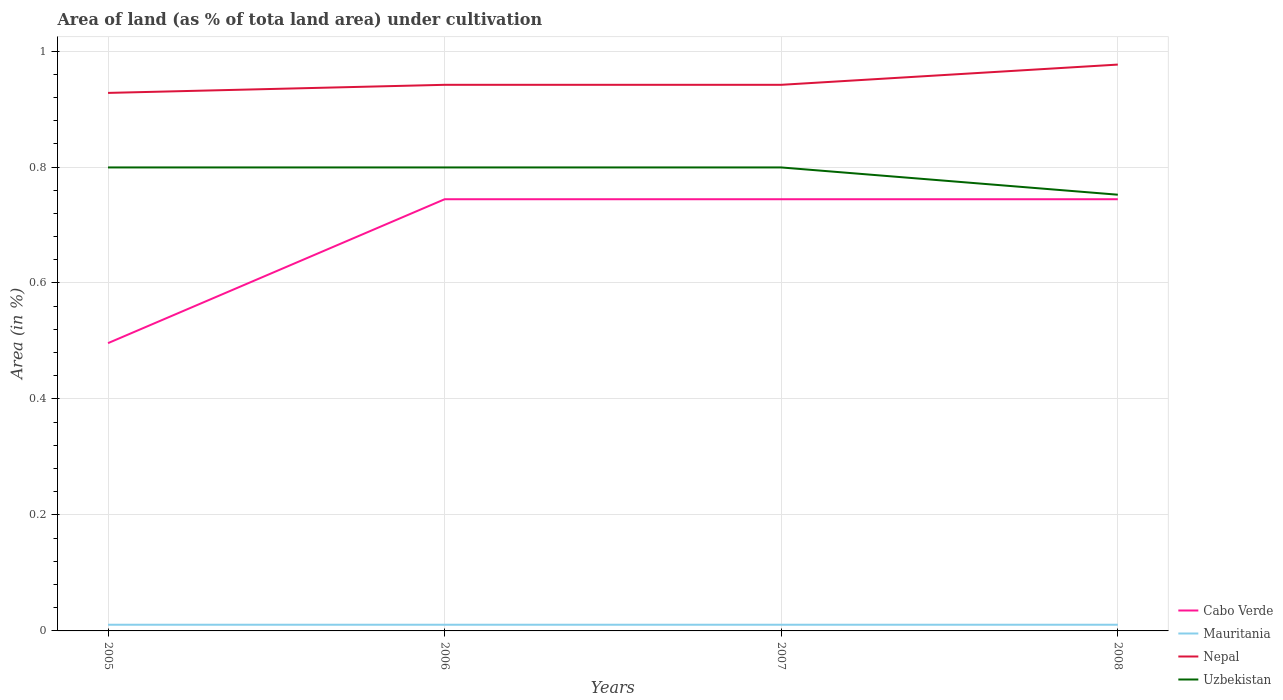How many different coloured lines are there?
Give a very brief answer. 4. Is the number of lines equal to the number of legend labels?
Keep it short and to the point. Yes. Across all years, what is the maximum percentage of land under cultivation in Nepal?
Offer a very short reply. 0.93. In which year was the percentage of land under cultivation in Mauritania maximum?
Provide a short and direct response. 2005. What is the total percentage of land under cultivation in Nepal in the graph?
Ensure brevity in your answer.  -0.03. What is the difference between the highest and the second highest percentage of land under cultivation in Cabo Verde?
Your answer should be very brief. 0.25. How many years are there in the graph?
Provide a short and direct response. 4. Does the graph contain grids?
Your response must be concise. Yes. Where does the legend appear in the graph?
Ensure brevity in your answer.  Bottom right. How many legend labels are there?
Provide a succinct answer. 4. What is the title of the graph?
Give a very brief answer. Area of land (as % of tota land area) under cultivation. What is the label or title of the Y-axis?
Offer a very short reply. Area (in %). What is the Area (in %) of Cabo Verde in 2005?
Ensure brevity in your answer.  0.5. What is the Area (in %) in Mauritania in 2005?
Your response must be concise. 0.01. What is the Area (in %) of Nepal in 2005?
Offer a very short reply. 0.93. What is the Area (in %) of Uzbekistan in 2005?
Offer a terse response. 0.8. What is the Area (in %) in Cabo Verde in 2006?
Ensure brevity in your answer.  0.74. What is the Area (in %) in Mauritania in 2006?
Ensure brevity in your answer.  0.01. What is the Area (in %) in Nepal in 2006?
Keep it short and to the point. 0.94. What is the Area (in %) of Uzbekistan in 2006?
Your answer should be compact. 0.8. What is the Area (in %) of Cabo Verde in 2007?
Ensure brevity in your answer.  0.74. What is the Area (in %) in Mauritania in 2007?
Ensure brevity in your answer.  0.01. What is the Area (in %) in Nepal in 2007?
Make the answer very short. 0.94. What is the Area (in %) in Uzbekistan in 2007?
Keep it short and to the point. 0.8. What is the Area (in %) of Cabo Verde in 2008?
Provide a short and direct response. 0.74. What is the Area (in %) of Mauritania in 2008?
Your answer should be compact. 0.01. What is the Area (in %) of Nepal in 2008?
Provide a succinct answer. 0.98. What is the Area (in %) in Uzbekistan in 2008?
Provide a short and direct response. 0.75. Across all years, what is the maximum Area (in %) in Cabo Verde?
Make the answer very short. 0.74. Across all years, what is the maximum Area (in %) in Mauritania?
Ensure brevity in your answer.  0.01. Across all years, what is the maximum Area (in %) in Nepal?
Keep it short and to the point. 0.98. Across all years, what is the maximum Area (in %) in Uzbekistan?
Make the answer very short. 0.8. Across all years, what is the minimum Area (in %) of Cabo Verde?
Keep it short and to the point. 0.5. Across all years, what is the minimum Area (in %) of Mauritania?
Provide a succinct answer. 0.01. Across all years, what is the minimum Area (in %) of Nepal?
Offer a terse response. 0.93. Across all years, what is the minimum Area (in %) in Uzbekistan?
Keep it short and to the point. 0.75. What is the total Area (in %) in Cabo Verde in the graph?
Offer a very short reply. 2.73. What is the total Area (in %) in Mauritania in the graph?
Offer a terse response. 0.04. What is the total Area (in %) of Nepal in the graph?
Provide a short and direct response. 3.79. What is the total Area (in %) in Uzbekistan in the graph?
Your answer should be compact. 3.15. What is the difference between the Area (in %) in Cabo Verde in 2005 and that in 2006?
Provide a succinct answer. -0.25. What is the difference between the Area (in %) in Nepal in 2005 and that in 2006?
Offer a terse response. -0.01. What is the difference between the Area (in %) of Cabo Verde in 2005 and that in 2007?
Your answer should be compact. -0.25. What is the difference between the Area (in %) in Nepal in 2005 and that in 2007?
Offer a terse response. -0.01. What is the difference between the Area (in %) of Cabo Verde in 2005 and that in 2008?
Make the answer very short. -0.25. What is the difference between the Area (in %) in Mauritania in 2005 and that in 2008?
Ensure brevity in your answer.  0. What is the difference between the Area (in %) in Nepal in 2005 and that in 2008?
Offer a very short reply. -0.05. What is the difference between the Area (in %) in Uzbekistan in 2005 and that in 2008?
Keep it short and to the point. 0.05. What is the difference between the Area (in %) of Nepal in 2006 and that in 2007?
Give a very brief answer. 0. What is the difference between the Area (in %) of Cabo Verde in 2006 and that in 2008?
Offer a terse response. 0. What is the difference between the Area (in %) in Nepal in 2006 and that in 2008?
Your response must be concise. -0.03. What is the difference between the Area (in %) of Uzbekistan in 2006 and that in 2008?
Provide a succinct answer. 0.05. What is the difference between the Area (in %) of Nepal in 2007 and that in 2008?
Keep it short and to the point. -0.03. What is the difference between the Area (in %) in Uzbekistan in 2007 and that in 2008?
Your answer should be very brief. 0.05. What is the difference between the Area (in %) of Cabo Verde in 2005 and the Area (in %) of Mauritania in 2006?
Your answer should be very brief. 0.49. What is the difference between the Area (in %) of Cabo Verde in 2005 and the Area (in %) of Nepal in 2006?
Your answer should be very brief. -0.45. What is the difference between the Area (in %) of Cabo Verde in 2005 and the Area (in %) of Uzbekistan in 2006?
Ensure brevity in your answer.  -0.3. What is the difference between the Area (in %) in Mauritania in 2005 and the Area (in %) in Nepal in 2006?
Provide a short and direct response. -0.93. What is the difference between the Area (in %) in Mauritania in 2005 and the Area (in %) in Uzbekistan in 2006?
Give a very brief answer. -0.79. What is the difference between the Area (in %) in Nepal in 2005 and the Area (in %) in Uzbekistan in 2006?
Your answer should be compact. 0.13. What is the difference between the Area (in %) in Cabo Verde in 2005 and the Area (in %) in Mauritania in 2007?
Offer a very short reply. 0.49. What is the difference between the Area (in %) of Cabo Verde in 2005 and the Area (in %) of Nepal in 2007?
Your response must be concise. -0.45. What is the difference between the Area (in %) of Cabo Verde in 2005 and the Area (in %) of Uzbekistan in 2007?
Provide a succinct answer. -0.3. What is the difference between the Area (in %) of Mauritania in 2005 and the Area (in %) of Nepal in 2007?
Your response must be concise. -0.93. What is the difference between the Area (in %) in Mauritania in 2005 and the Area (in %) in Uzbekistan in 2007?
Offer a terse response. -0.79. What is the difference between the Area (in %) of Nepal in 2005 and the Area (in %) of Uzbekistan in 2007?
Your answer should be compact. 0.13. What is the difference between the Area (in %) in Cabo Verde in 2005 and the Area (in %) in Mauritania in 2008?
Offer a terse response. 0.49. What is the difference between the Area (in %) in Cabo Verde in 2005 and the Area (in %) in Nepal in 2008?
Your answer should be compact. -0.48. What is the difference between the Area (in %) in Cabo Verde in 2005 and the Area (in %) in Uzbekistan in 2008?
Make the answer very short. -0.26. What is the difference between the Area (in %) of Mauritania in 2005 and the Area (in %) of Nepal in 2008?
Your answer should be very brief. -0.97. What is the difference between the Area (in %) of Mauritania in 2005 and the Area (in %) of Uzbekistan in 2008?
Keep it short and to the point. -0.74. What is the difference between the Area (in %) of Nepal in 2005 and the Area (in %) of Uzbekistan in 2008?
Ensure brevity in your answer.  0.18. What is the difference between the Area (in %) in Cabo Verde in 2006 and the Area (in %) in Mauritania in 2007?
Make the answer very short. 0.73. What is the difference between the Area (in %) of Cabo Verde in 2006 and the Area (in %) of Nepal in 2007?
Provide a short and direct response. -0.2. What is the difference between the Area (in %) in Cabo Verde in 2006 and the Area (in %) in Uzbekistan in 2007?
Offer a terse response. -0.05. What is the difference between the Area (in %) in Mauritania in 2006 and the Area (in %) in Nepal in 2007?
Provide a succinct answer. -0.93. What is the difference between the Area (in %) in Mauritania in 2006 and the Area (in %) in Uzbekistan in 2007?
Make the answer very short. -0.79. What is the difference between the Area (in %) in Nepal in 2006 and the Area (in %) in Uzbekistan in 2007?
Your response must be concise. 0.14. What is the difference between the Area (in %) in Cabo Verde in 2006 and the Area (in %) in Mauritania in 2008?
Keep it short and to the point. 0.73. What is the difference between the Area (in %) of Cabo Verde in 2006 and the Area (in %) of Nepal in 2008?
Keep it short and to the point. -0.23. What is the difference between the Area (in %) of Cabo Verde in 2006 and the Area (in %) of Uzbekistan in 2008?
Keep it short and to the point. -0.01. What is the difference between the Area (in %) in Mauritania in 2006 and the Area (in %) in Nepal in 2008?
Your response must be concise. -0.97. What is the difference between the Area (in %) of Mauritania in 2006 and the Area (in %) of Uzbekistan in 2008?
Offer a terse response. -0.74. What is the difference between the Area (in %) of Nepal in 2006 and the Area (in %) of Uzbekistan in 2008?
Offer a terse response. 0.19. What is the difference between the Area (in %) of Cabo Verde in 2007 and the Area (in %) of Mauritania in 2008?
Ensure brevity in your answer.  0.73. What is the difference between the Area (in %) of Cabo Verde in 2007 and the Area (in %) of Nepal in 2008?
Your response must be concise. -0.23. What is the difference between the Area (in %) in Cabo Verde in 2007 and the Area (in %) in Uzbekistan in 2008?
Make the answer very short. -0.01. What is the difference between the Area (in %) of Mauritania in 2007 and the Area (in %) of Nepal in 2008?
Offer a terse response. -0.97. What is the difference between the Area (in %) of Mauritania in 2007 and the Area (in %) of Uzbekistan in 2008?
Your answer should be compact. -0.74. What is the difference between the Area (in %) in Nepal in 2007 and the Area (in %) in Uzbekistan in 2008?
Your response must be concise. 0.19. What is the average Area (in %) in Cabo Verde per year?
Ensure brevity in your answer.  0.68. What is the average Area (in %) of Mauritania per year?
Ensure brevity in your answer.  0.01. What is the average Area (in %) of Nepal per year?
Give a very brief answer. 0.95. What is the average Area (in %) in Uzbekistan per year?
Your answer should be very brief. 0.79. In the year 2005, what is the difference between the Area (in %) in Cabo Verde and Area (in %) in Mauritania?
Your answer should be very brief. 0.49. In the year 2005, what is the difference between the Area (in %) in Cabo Verde and Area (in %) in Nepal?
Offer a very short reply. -0.43. In the year 2005, what is the difference between the Area (in %) of Cabo Verde and Area (in %) of Uzbekistan?
Provide a short and direct response. -0.3. In the year 2005, what is the difference between the Area (in %) of Mauritania and Area (in %) of Nepal?
Make the answer very short. -0.92. In the year 2005, what is the difference between the Area (in %) in Mauritania and Area (in %) in Uzbekistan?
Make the answer very short. -0.79. In the year 2005, what is the difference between the Area (in %) of Nepal and Area (in %) of Uzbekistan?
Give a very brief answer. 0.13. In the year 2006, what is the difference between the Area (in %) of Cabo Verde and Area (in %) of Mauritania?
Keep it short and to the point. 0.73. In the year 2006, what is the difference between the Area (in %) in Cabo Verde and Area (in %) in Nepal?
Provide a short and direct response. -0.2. In the year 2006, what is the difference between the Area (in %) of Cabo Verde and Area (in %) of Uzbekistan?
Make the answer very short. -0.05. In the year 2006, what is the difference between the Area (in %) in Mauritania and Area (in %) in Nepal?
Keep it short and to the point. -0.93. In the year 2006, what is the difference between the Area (in %) of Mauritania and Area (in %) of Uzbekistan?
Your response must be concise. -0.79. In the year 2006, what is the difference between the Area (in %) of Nepal and Area (in %) of Uzbekistan?
Make the answer very short. 0.14. In the year 2007, what is the difference between the Area (in %) of Cabo Verde and Area (in %) of Mauritania?
Provide a succinct answer. 0.73. In the year 2007, what is the difference between the Area (in %) of Cabo Verde and Area (in %) of Nepal?
Provide a short and direct response. -0.2. In the year 2007, what is the difference between the Area (in %) of Cabo Verde and Area (in %) of Uzbekistan?
Ensure brevity in your answer.  -0.05. In the year 2007, what is the difference between the Area (in %) in Mauritania and Area (in %) in Nepal?
Ensure brevity in your answer.  -0.93. In the year 2007, what is the difference between the Area (in %) in Mauritania and Area (in %) in Uzbekistan?
Provide a short and direct response. -0.79. In the year 2007, what is the difference between the Area (in %) in Nepal and Area (in %) in Uzbekistan?
Offer a very short reply. 0.14. In the year 2008, what is the difference between the Area (in %) in Cabo Verde and Area (in %) in Mauritania?
Keep it short and to the point. 0.73. In the year 2008, what is the difference between the Area (in %) in Cabo Verde and Area (in %) in Nepal?
Ensure brevity in your answer.  -0.23. In the year 2008, what is the difference between the Area (in %) in Cabo Verde and Area (in %) in Uzbekistan?
Provide a short and direct response. -0.01. In the year 2008, what is the difference between the Area (in %) in Mauritania and Area (in %) in Nepal?
Offer a terse response. -0.97. In the year 2008, what is the difference between the Area (in %) in Mauritania and Area (in %) in Uzbekistan?
Offer a terse response. -0.74. In the year 2008, what is the difference between the Area (in %) of Nepal and Area (in %) of Uzbekistan?
Your answer should be compact. 0.22. What is the ratio of the Area (in %) in Cabo Verde in 2005 to that in 2006?
Your answer should be compact. 0.67. What is the ratio of the Area (in %) in Mauritania in 2005 to that in 2006?
Provide a succinct answer. 1. What is the ratio of the Area (in %) in Nepal in 2005 to that in 2006?
Ensure brevity in your answer.  0.99. What is the ratio of the Area (in %) in Uzbekistan in 2005 to that in 2006?
Your answer should be very brief. 1. What is the ratio of the Area (in %) of Cabo Verde in 2005 to that in 2007?
Your response must be concise. 0.67. What is the ratio of the Area (in %) in Nepal in 2005 to that in 2007?
Offer a very short reply. 0.99. What is the ratio of the Area (in %) of Uzbekistan in 2005 to that in 2007?
Your answer should be very brief. 1. What is the ratio of the Area (in %) of Cabo Verde in 2005 to that in 2008?
Keep it short and to the point. 0.67. What is the ratio of the Area (in %) in Mauritania in 2005 to that in 2008?
Your answer should be very brief. 1. What is the ratio of the Area (in %) of Nepal in 2006 to that in 2007?
Your answer should be very brief. 1. What is the ratio of the Area (in %) of Uzbekistan in 2006 to that in 2007?
Your response must be concise. 1. What is the ratio of the Area (in %) in Nepal in 2006 to that in 2008?
Give a very brief answer. 0.96. What is the ratio of the Area (in %) of Uzbekistan in 2006 to that in 2008?
Ensure brevity in your answer.  1.06. What is the ratio of the Area (in %) in Mauritania in 2007 to that in 2008?
Provide a short and direct response. 1. What is the ratio of the Area (in %) in Uzbekistan in 2007 to that in 2008?
Your answer should be very brief. 1.06. What is the difference between the highest and the second highest Area (in %) of Cabo Verde?
Keep it short and to the point. 0. What is the difference between the highest and the second highest Area (in %) of Mauritania?
Keep it short and to the point. 0. What is the difference between the highest and the second highest Area (in %) in Nepal?
Give a very brief answer. 0.03. What is the difference between the highest and the second highest Area (in %) of Uzbekistan?
Your answer should be very brief. 0. What is the difference between the highest and the lowest Area (in %) in Cabo Verde?
Offer a terse response. 0.25. What is the difference between the highest and the lowest Area (in %) of Nepal?
Keep it short and to the point. 0.05. What is the difference between the highest and the lowest Area (in %) in Uzbekistan?
Make the answer very short. 0.05. 